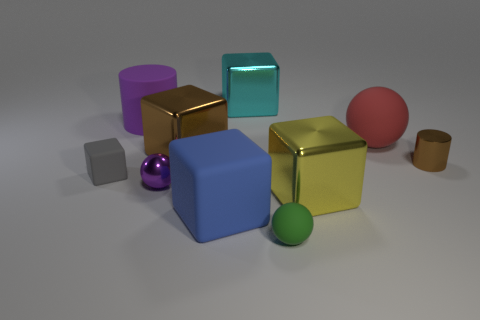Subtract all tiny rubber spheres. How many spheres are left? 2 Subtract 2 cubes. How many cubes are left? 3 Subtract all cyan blocks. How many blocks are left? 4 Subtract all balls. How many objects are left? 7 Add 2 cyan things. How many cyan things are left? 3 Add 1 large brown shiny blocks. How many large brown shiny blocks exist? 2 Subtract 0 green cylinders. How many objects are left? 10 Subtract all brown balls. Subtract all red blocks. How many balls are left? 3 Subtract all big red spheres. Subtract all matte objects. How many objects are left? 4 